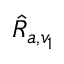Convert formula to latex. <formula><loc_0><loc_0><loc_500><loc_500>\hat { R } _ { a , v _ { 1 } }</formula> 